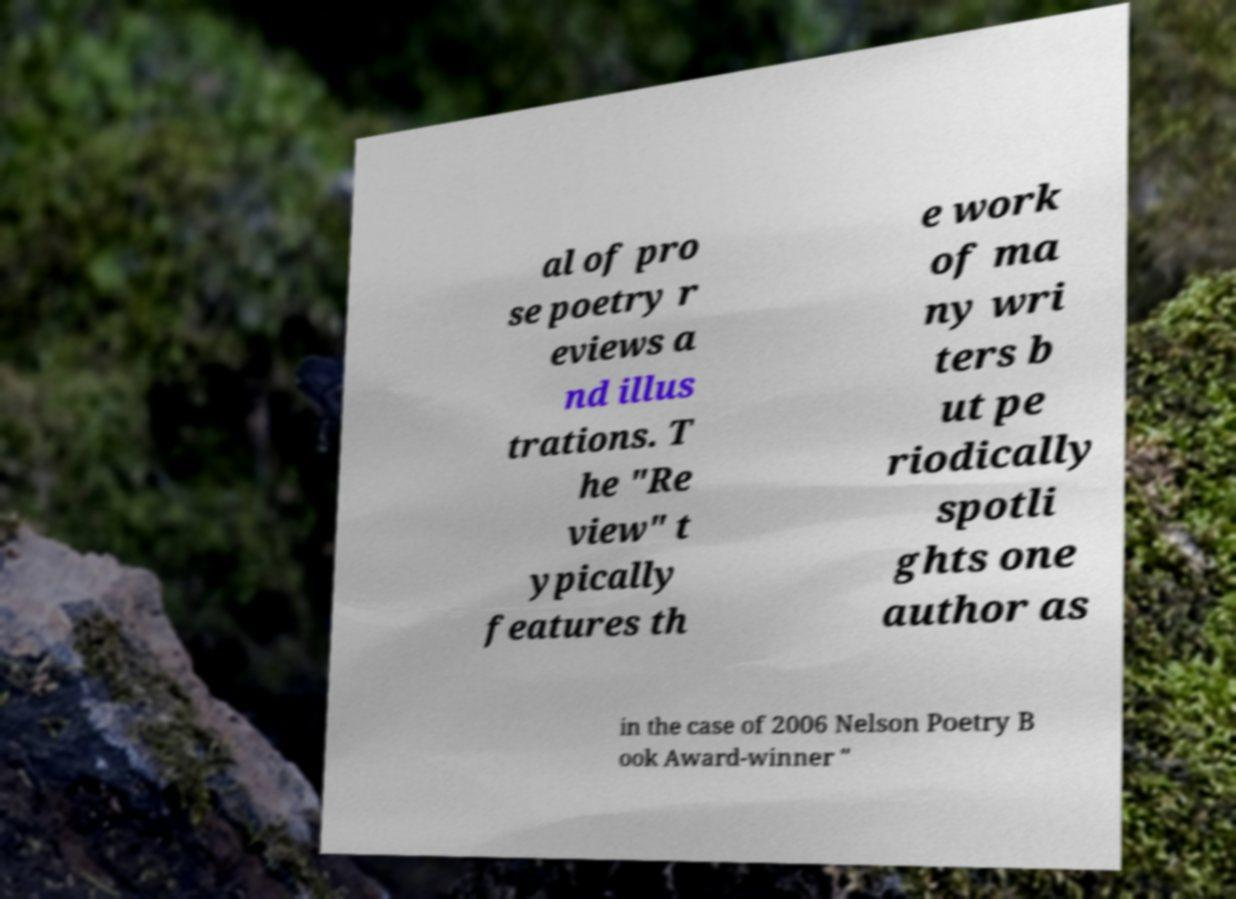For documentation purposes, I need the text within this image transcribed. Could you provide that? al of pro se poetry r eviews a nd illus trations. T he "Re view" t ypically features th e work of ma ny wri ters b ut pe riodically spotli ghts one author as in the case of 2006 Nelson Poetry B ook Award-winner " 